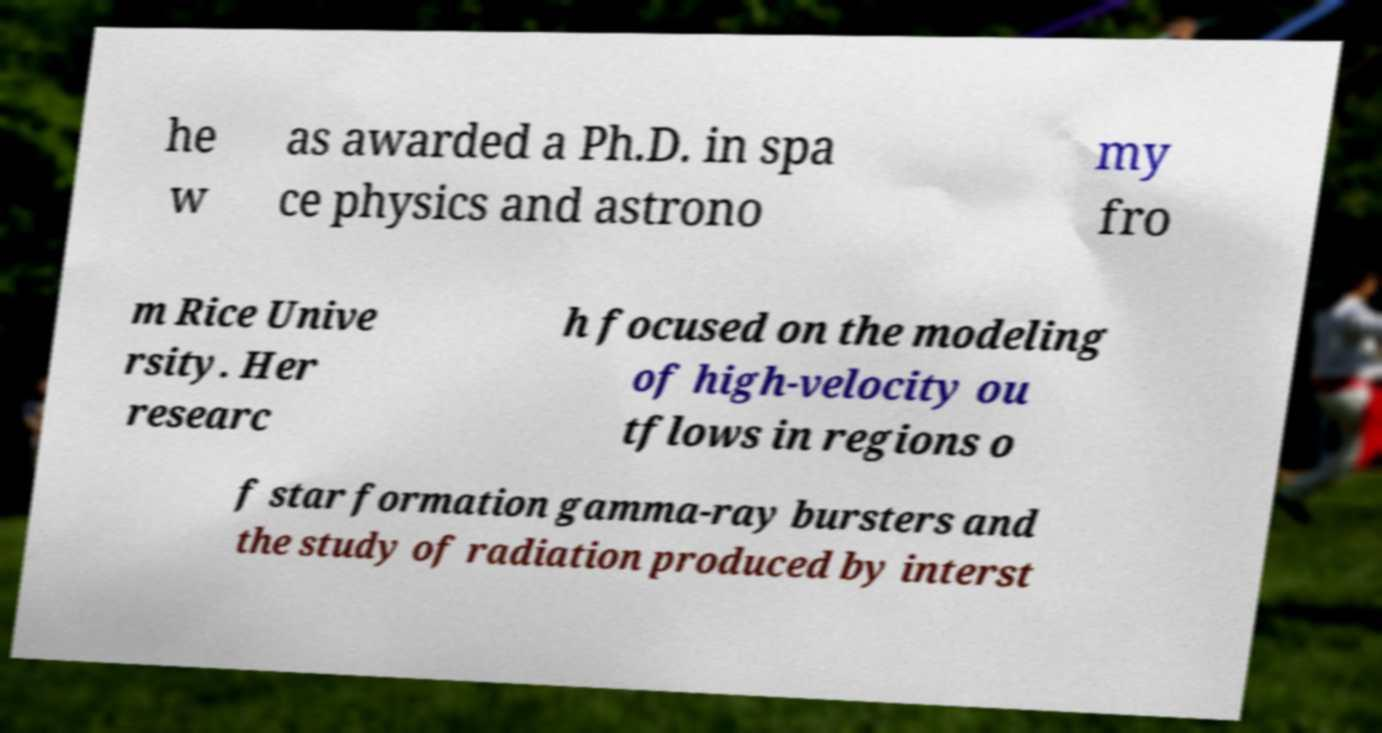For documentation purposes, I need the text within this image transcribed. Could you provide that? he w as awarded a Ph.D. in spa ce physics and astrono my fro m Rice Unive rsity. Her researc h focused on the modeling of high-velocity ou tflows in regions o f star formation gamma-ray bursters and the study of radiation produced by interst 